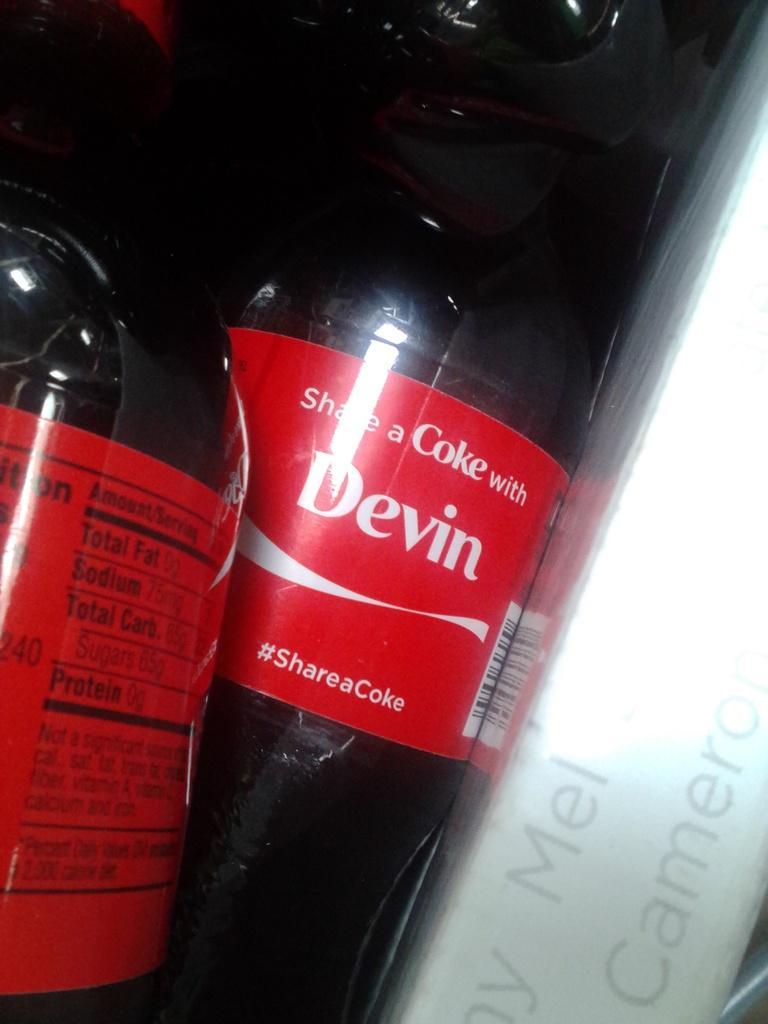Could you give a brief overview of what you see in this image? Here we can see a drink and some liquid in it, and here is the label on it. 